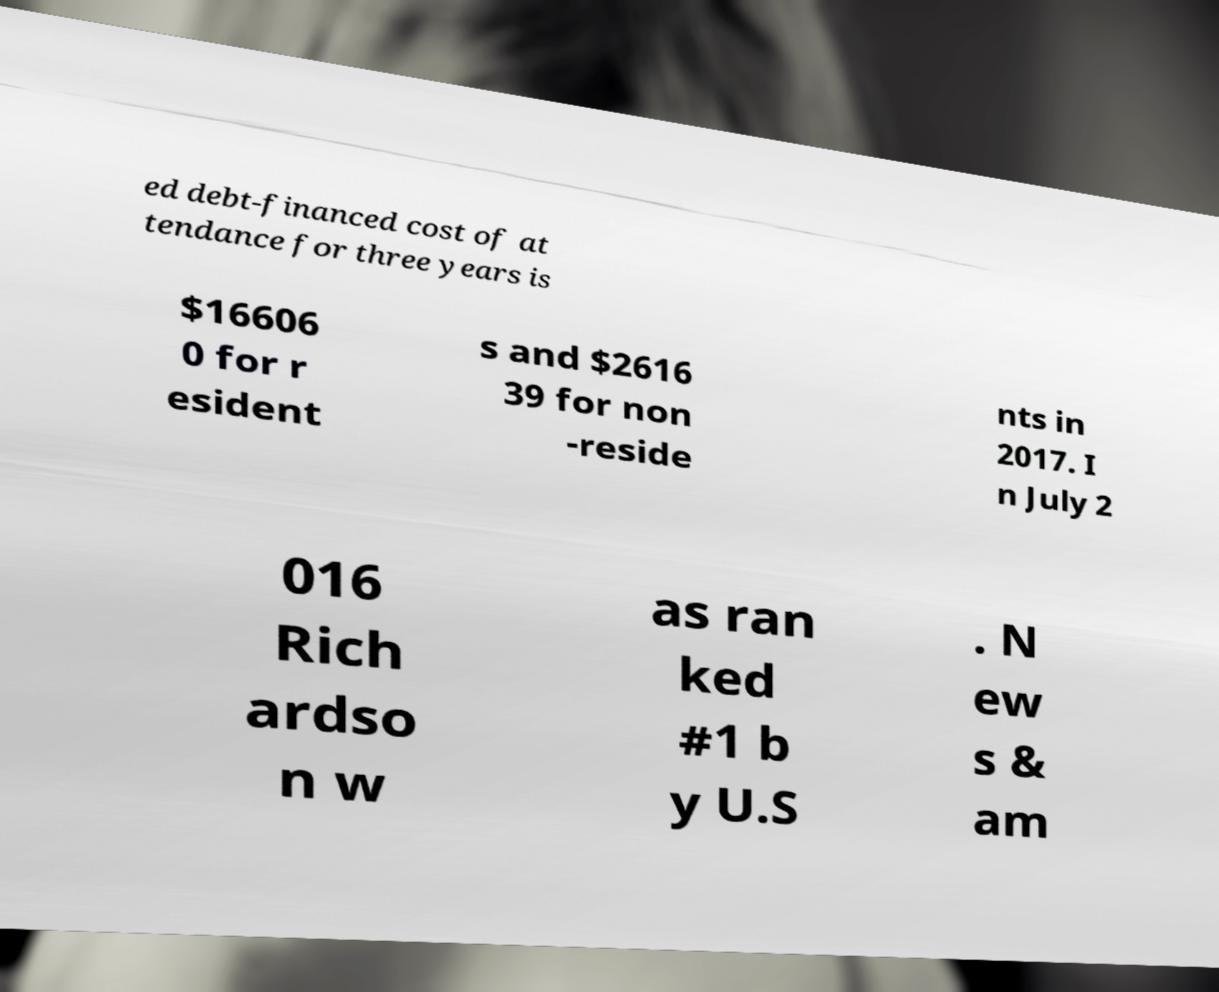For documentation purposes, I need the text within this image transcribed. Could you provide that? ed debt-financed cost of at tendance for three years is $16606 0 for r esident s and $2616 39 for non -reside nts in 2017. I n July 2 016 Rich ardso n w as ran ked #1 b y U.S . N ew s & am 